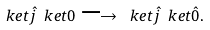Convert formula to latex. <formula><loc_0><loc_0><loc_500><loc_500>\ k e t { \hat { j } } \ k e t { 0 } \longrightarrow \ k e t { \hat { j } } \ k e t { \hat { 0 } } .</formula> 